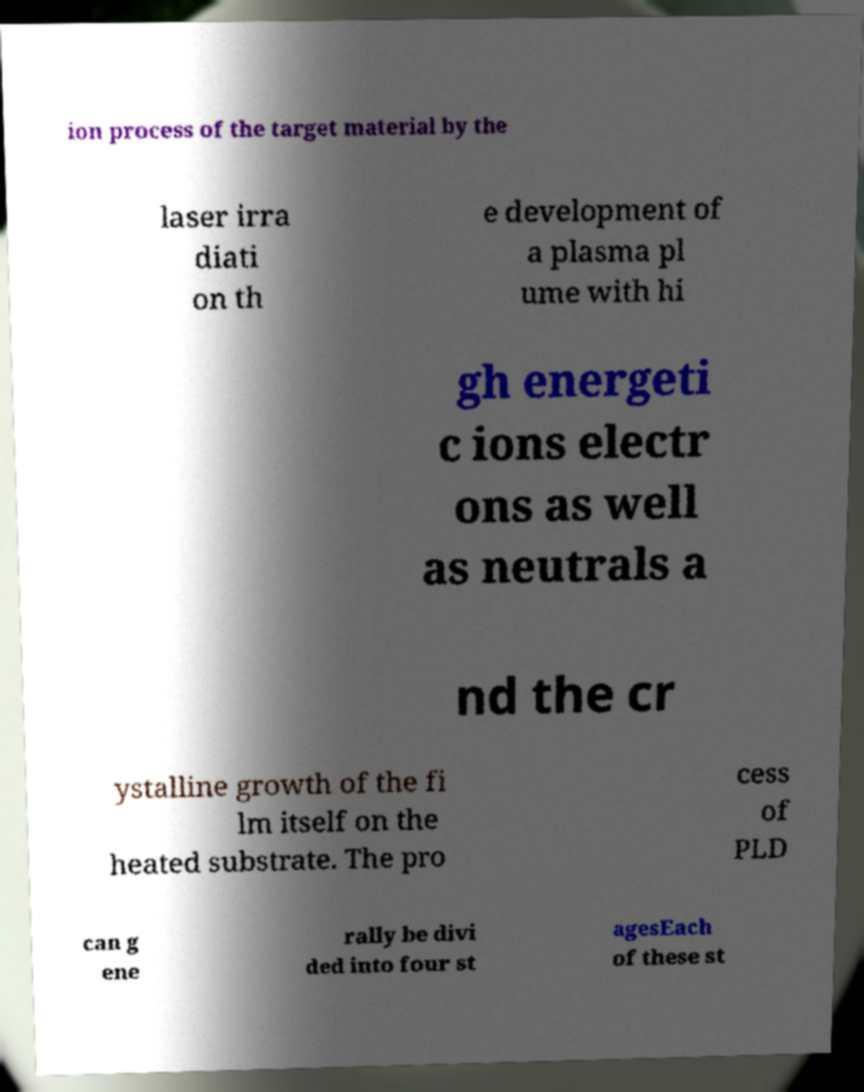Could you assist in decoding the text presented in this image and type it out clearly? ion process of the target material by the laser irra diati on th e development of a plasma pl ume with hi gh energeti c ions electr ons as well as neutrals a nd the cr ystalline growth of the fi lm itself on the heated substrate. The pro cess of PLD can g ene rally be divi ded into four st agesEach of these st 